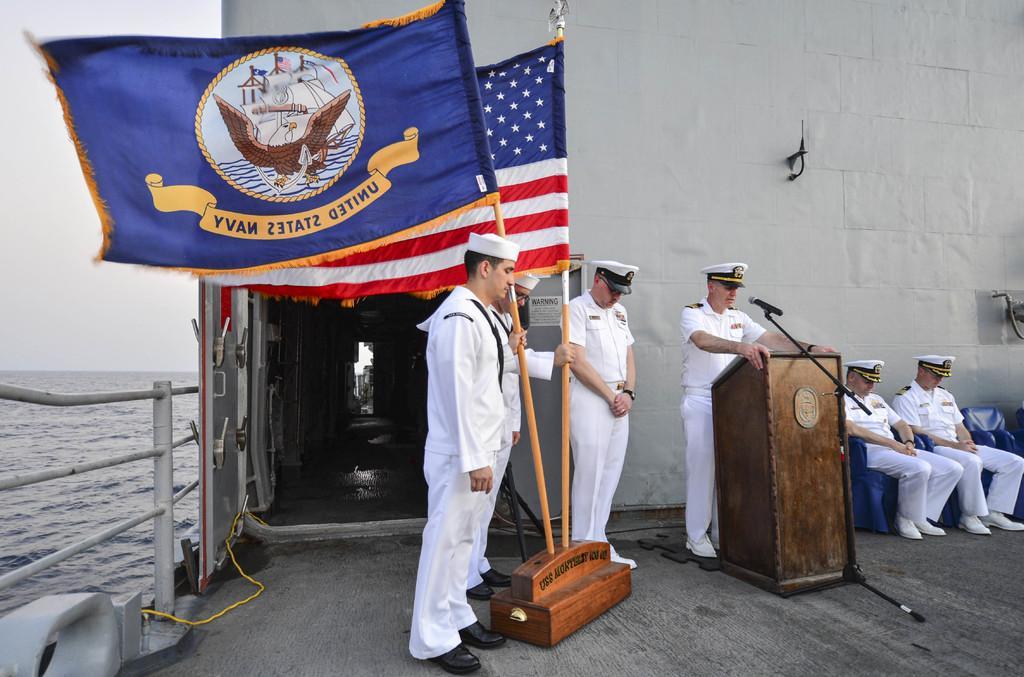Describe this image in one or two sentences. In this image we can see few people and the place looks like a ship on the water. We can see a person standing and there is a podium with mic in front of him and we can see two flags. 